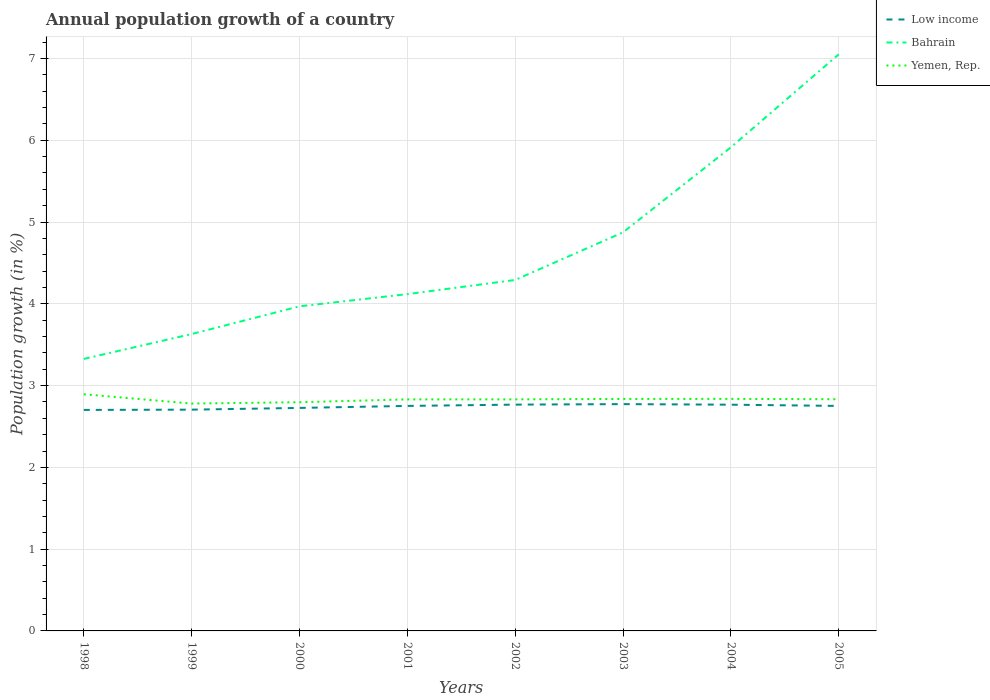How many different coloured lines are there?
Offer a very short reply. 3. Across all years, what is the maximum annual population growth in Yemen, Rep.?
Offer a very short reply. 2.78. In which year was the annual population growth in Yemen, Rep. maximum?
Offer a very short reply. 1999. What is the total annual population growth in Low income in the graph?
Provide a short and direct response. -0.06. What is the difference between the highest and the second highest annual population growth in Bahrain?
Your answer should be compact. 3.72. Is the annual population growth in Bahrain strictly greater than the annual population growth in Low income over the years?
Your answer should be compact. No. How many years are there in the graph?
Offer a very short reply. 8. What is the difference between two consecutive major ticks on the Y-axis?
Your response must be concise. 1. Where does the legend appear in the graph?
Your response must be concise. Top right. How many legend labels are there?
Offer a very short reply. 3. How are the legend labels stacked?
Give a very brief answer. Vertical. What is the title of the graph?
Ensure brevity in your answer.  Annual population growth of a country. What is the label or title of the Y-axis?
Ensure brevity in your answer.  Population growth (in %). What is the Population growth (in %) in Low income in 1998?
Keep it short and to the point. 2.7. What is the Population growth (in %) of Bahrain in 1998?
Provide a short and direct response. 3.33. What is the Population growth (in %) of Yemen, Rep. in 1998?
Your response must be concise. 2.89. What is the Population growth (in %) in Low income in 1999?
Provide a succinct answer. 2.71. What is the Population growth (in %) in Bahrain in 1999?
Your response must be concise. 3.63. What is the Population growth (in %) in Yemen, Rep. in 1999?
Make the answer very short. 2.78. What is the Population growth (in %) of Low income in 2000?
Keep it short and to the point. 2.73. What is the Population growth (in %) in Bahrain in 2000?
Offer a very short reply. 3.97. What is the Population growth (in %) in Yemen, Rep. in 2000?
Give a very brief answer. 2.8. What is the Population growth (in %) of Low income in 2001?
Provide a succinct answer. 2.75. What is the Population growth (in %) in Bahrain in 2001?
Provide a succinct answer. 4.12. What is the Population growth (in %) of Yemen, Rep. in 2001?
Your answer should be very brief. 2.83. What is the Population growth (in %) in Low income in 2002?
Provide a succinct answer. 2.77. What is the Population growth (in %) of Bahrain in 2002?
Ensure brevity in your answer.  4.29. What is the Population growth (in %) in Yemen, Rep. in 2002?
Provide a short and direct response. 2.83. What is the Population growth (in %) of Low income in 2003?
Provide a short and direct response. 2.77. What is the Population growth (in %) of Bahrain in 2003?
Provide a short and direct response. 4.87. What is the Population growth (in %) in Yemen, Rep. in 2003?
Give a very brief answer. 2.84. What is the Population growth (in %) of Low income in 2004?
Provide a short and direct response. 2.77. What is the Population growth (in %) in Bahrain in 2004?
Your response must be concise. 5.91. What is the Population growth (in %) of Yemen, Rep. in 2004?
Your response must be concise. 2.84. What is the Population growth (in %) in Low income in 2005?
Your answer should be very brief. 2.75. What is the Population growth (in %) in Bahrain in 2005?
Ensure brevity in your answer.  7.05. What is the Population growth (in %) of Yemen, Rep. in 2005?
Provide a short and direct response. 2.83. Across all years, what is the maximum Population growth (in %) in Low income?
Keep it short and to the point. 2.77. Across all years, what is the maximum Population growth (in %) of Bahrain?
Ensure brevity in your answer.  7.05. Across all years, what is the maximum Population growth (in %) of Yemen, Rep.?
Make the answer very short. 2.89. Across all years, what is the minimum Population growth (in %) in Low income?
Offer a terse response. 2.7. Across all years, what is the minimum Population growth (in %) in Bahrain?
Your response must be concise. 3.33. Across all years, what is the minimum Population growth (in %) of Yemen, Rep.?
Give a very brief answer. 2.78. What is the total Population growth (in %) in Low income in the graph?
Your answer should be compact. 21.95. What is the total Population growth (in %) of Bahrain in the graph?
Your answer should be very brief. 37.17. What is the total Population growth (in %) of Yemen, Rep. in the graph?
Provide a succinct answer. 22.64. What is the difference between the Population growth (in %) in Low income in 1998 and that in 1999?
Your response must be concise. -0. What is the difference between the Population growth (in %) in Bahrain in 1998 and that in 1999?
Keep it short and to the point. -0.3. What is the difference between the Population growth (in %) of Yemen, Rep. in 1998 and that in 1999?
Provide a succinct answer. 0.11. What is the difference between the Population growth (in %) of Low income in 1998 and that in 2000?
Offer a very short reply. -0.02. What is the difference between the Population growth (in %) in Bahrain in 1998 and that in 2000?
Your response must be concise. -0.64. What is the difference between the Population growth (in %) of Yemen, Rep. in 1998 and that in 2000?
Provide a short and direct response. 0.1. What is the difference between the Population growth (in %) in Low income in 1998 and that in 2001?
Your response must be concise. -0.05. What is the difference between the Population growth (in %) in Bahrain in 1998 and that in 2001?
Provide a short and direct response. -0.79. What is the difference between the Population growth (in %) in Yemen, Rep. in 1998 and that in 2001?
Your response must be concise. 0.06. What is the difference between the Population growth (in %) of Low income in 1998 and that in 2002?
Offer a terse response. -0.06. What is the difference between the Population growth (in %) of Bahrain in 1998 and that in 2002?
Provide a succinct answer. -0.97. What is the difference between the Population growth (in %) of Yemen, Rep. in 1998 and that in 2002?
Give a very brief answer. 0.06. What is the difference between the Population growth (in %) of Low income in 1998 and that in 2003?
Your answer should be compact. -0.07. What is the difference between the Population growth (in %) in Bahrain in 1998 and that in 2003?
Your answer should be very brief. -1.55. What is the difference between the Population growth (in %) in Yemen, Rep. in 1998 and that in 2003?
Offer a terse response. 0.06. What is the difference between the Population growth (in %) of Low income in 1998 and that in 2004?
Make the answer very short. -0.06. What is the difference between the Population growth (in %) of Bahrain in 1998 and that in 2004?
Offer a very short reply. -2.59. What is the difference between the Population growth (in %) in Yemen, Rep. in 1998 and that in 2004?
Offer a terse response. 0.06. What is the difference between the Population growth (in %) in Low income in 1998 and that in 2005?
Give a very brief answer. -0.05. What is the difference between the Population growth (in %) of Bahrain in 1998 and that in 2005?
Make the answer very short. -3.72. What is the difference between the Population growth (in %) in Yemen, Rep. in 1998 and that in 2005?
Provide a short and direct response. 0.06. What is the difference between the Population growth (in %) of Low income in 1999 and that in 2000?
Give a very brief answer. -0.02. What is the difference between the Population growth (in %) of Bahrain in 1999 and that in 2000?
Provide a short and direct response. -0.34. What is the difference between the Population growth (in %) of Yemen, Rep. in 1999 and that in 2000?
Offer a very short reply. -0.02. What is the difference between the Population growth (in %) in Low income in 1999 and that in 2001?
Make the answer very short. -0.05. What is the difference between the Population growth (in %) in Bahrain in 1999 and that in 2001?
Provide a short and direct response. -0.49. What is the difference between the Population growth (in %) of Yemen, Rep. in 1999 and that in 2001?
Make the answer very short. -0.05. What is the difference between the Population growth (in %) in Low income in 1999 and that in 2002?
Your response must be concise. -0.06. What is the difference between the Population growth (in %) in Bahrain in 1999 and that in 2002?
Your response must be concise. -0.66. What is the difference between the Population growth (in %) in Yemen, Rep. in 1999 and that in 2002?
Make the answer very short. -0.05. What is the difference between the Population growth (in %) in Low income in 1999 and that in 2003?
Give a very brief answer. -0.07. What is the difference between the Population growth (in %) in Bahrain in 1999 and that in 2003?
Make the answer very short. -1.24. What is the difference between the Population growth (in %) of Yemen, Rep. in 1999 and that in 2003?
Provide a short and direct response. -0.06. What is the difference between the Population growth (in %) of Low income in 1999 and that in 2004?
Keep it short and to the point. -0.06. What is the difference between the Population growth (in %) of Bahrain in 1999 and that in 2004?
Your answer should be compact. -2.28. What is the difference between the Population growth (in %) in Yemen, Rep. in 1999 and that in 2004?
Ensure brevity in your answer.  -0.06. What is the difference between the Population growth (in %) of Low income in 1999 and that in 2005?
Your response must be concise. -0.05. What is the difference between the Population growth (in %) of Bahrain in 1999 and that in 2005?
Your response must be concise. -3.42. What is the difference between the Population growth (in %) in Yemen, Rep. in 1999 and that in 2005?
Make the answer very short. -0.05. What is the difference between the Population growth (in %) of Low income in 2000 and that in 2001?
Your response must be concise. -0.02. What is the difference between the Population growth (in %) of Bahrain in 2000 and that in 2001?
Ensure brevity in your answer.  -0.15. What is the difference between the Population growth (in %) of Yemen, Rep. in 2000 and that in 2001?
Keep it short and to the point. -0.03. What is the difference between the Population growth (in %) of Low income in 2000 and that in 2002?
Offer a very short reply. -0.04. What is the difference between the Population growth (in %) of Bahrain in 2000 and that in 2002?
Offer a very short reply. -0.32. What is the difference between the Population growth (in %) of Yemen, Rep. in 2000 and that in 2002?
Provide a succinct answer. -0.04. What is the difference between the Population growth (in %) of Low income in 2000 and that in 2003?
Provide a short and direct response. -0.05. What is the difference between the Population growth (in %) in Bahrain in 2000 and that in 2003?
Your answer should be compact. -0.9. What is the difference between the Population growth (in %) of Yemen, Rep. in 2000 and that in 2003?
Offer a terse response. -0.04. What is the difference between the Population growth (in %) of Low income in 2000 and that in 2004?
Ensure brevity in your answer.  -0.04. What is the difference between the Population growth (in %) of Bahrain in 2000 and that in 2004?
Offer a terse response. -1.94. What is the difference between the Population growth (in %) of Yemen, Rep. in 2000 and that in 2004?
Your answer should be very brief. -0.04. What is the difference between the Population growth (in %) in Low income in 2000 and that in 2005?
Your answer should be very brief. -0.02. What is the difference between the Population growth (in %) of Bahrain in 2000 and that in 2005?
Offer a terse response. -3.08. What is the difference between the Population growth (in %) of Yemen, Rep. in 2000 and that in 2005?
Your answer should be very brief. -0.04. What is the difference between the Population growth (in %) in Low income in 2001 and that in 2002?
Your answer should be very brief. -0.02. What is the difference between the Population growth (in %) of Bahrain in 2001 and that in 2002?
Offer a very short reply. -0.17. What is the difference between the Population growth (in %) in Yemen, Rep. in 2001 and that in 2002?
Your answer should be very brief. -0. What is the difference between the Population growth (in %) of Low income in 2001 and that in 2003?
Your response must be concise. -0.02. What is the difference between the Population growth (in %) in Bahrain in 2001 and that in 2003?
Make the answer very short. -0.76. What is the difference between the Population growth (in %) of Yemen, Rep. in 2001 and that in 2003?
Your answer should be compact. -0.01. What is the difference between the Population growth (in %) in Low income in 2001 and that in 2004?
Your answer should be compact. -0.01. What is the difference between the Population growth (in %) in Bahrain in 2001 and that in 2004?
Provide a succinct answer. -1.79. What is the difference between the Population growth (in %) of Yemen, Rep. in 2001 and that in 2004?
Offer a terse response. -0.01. What is the difference between the Population growth (in %) of Low income in 2001 and that in 2005?
Ensure brevity in your answer.  0. What is the difference between the Population growth (in %) of Bahrain in 2001 and that in 2005?
Make the answer very short. -2.93. What is the difference between the Population growth (in %) of Yemen, Rep. in 2001 and that in 2005?
Give a very brief answer. -0. What is the difference between the Population growth (in %) of Low income in 2002 and that in 2003?
Ensure brevity in your answer.  -0.01. What is the difference between the Population growth (in %) of Bahrain in 2002 and that in 2003?
Provide a succinct answer. -0.58. What is the difference between the Population growth (in %) of Yemen, Rep. in 2002 and that in 2003?
Your response must be concise. -0.01. What is the difference between the Population growth (in %) of Low income in 2002 and that in 2004?
Provide a succinct answer. 0. What is the difference between the Population growth (in %) in Bahrain in 2002 and that in 2004?
Your response must be concise. -1.62. What is the difference between the Population growth (in %) in Yemen, Rep. in 2002 and that in 2004?
Your response must be concise. -0.01. What is the difference between the Population growth (in %) of Low income in 2002 and that in 2005?
Offer a very short reply. 0.02. What is the difference between the Population growth (in %) of Bahrain in 2002 and that in 2005?
Keep it short and to the point. -2.76. What is the difference between the Population growth (in %) of Yemen, Rep. in 2002 and that in 2005?
Give a very brief answer. -0. What is the difference between the Population growth (in %) in Low income in 2003 and that in 2004?
Your response must be concise. 0.01. What is the difference between the Population growth (in %) of Bahrain in 2003 and that in 2004?
Offer a very short reply. -1.04. What is the difference between the Population growth (in %) of Yemen, Rep. in 2003 and that in 2004?
Ensure brevity in your answer.  -0. What is the difference between the Population growth (in %) in Low income in 2003 and that in 2005?
Ensure brevity in your answer.  0.02. What is the difference between the Population growth (in %) in Bahrain in 2003 and that in 2005?
Give a very brief answer. -2.18. What is the difference between the Population growth (in %) in Yemen, Rep. in 2003 and that in 2005?
Make the answer very short. 0. What is the difference between the Population growth (in %) in Low income in 2004 and that in 2005?
Offer a very short reply. 0.02. What is the difference between the Population growth (in %) of Bahrain in 2004 and that in 2005?
Offer a terse response. -1.14. What is the difference between the Population growth (in %) of Yemen, Rep. in 2004 and that in 2005?
Provide a succinct answer. 0. What is the difference between the Population growth (in %) of Low income in 1998 and the Population growth (in %) of Bahrain in 1999?
Keep it short and to the point. -0.93. What is the difference between the Population growth (in %) of Low income in 1998 and the Population growth (in %) of Yemen, Rep. in 1999?
Your response must be concise. -0.08. What is the difference between the Population growth (in %) of Bahrain in 1998 and the Population growth (in %) of Yemen, Rep. in 1999?
Provide a short and direct response. 0.55. What is the difference between the Population growth (in %) of Low income in 1998 and the Population growth (in %) of Bahrain in 2000?
Provide a short and direct response. -1.27. What is the difference between the Population growth (in %) of Low income in 1998 and the Population growth (in %) of Yemen, Rep. in 2000?
Give a very brief answer. -0.09. What is the difference between the Population growth (in %) of Bahrain in 1998 and the Population growth (in %) of Yemen, Rep. in 2000?
Make the answer very short. 0.53. What is the difference between the Population growth (in %) of Low income in 1998 and the Population growth (in %) of Bahrain in 2001?
Ensure brevity in your answer.  -1.42. What is the difference between the Population growth (in %) in Low income in 1998 and the Population growth (in %) in Yemen, Rep. in 2001?
Your answer should be compact. -0.13. What is the difference between the Population growth (in %) of Bahrain in 1998 and the Population growth (in %) of Yemen, Rep. in 2001?
Offer a terse response. 0.49. What is the difference between the Population growth (in %) in Low income in 1998 and the Population growth (in %) in Bahrain in 2002?
Your response must be concise. -1.59. What is the difference between the Population growth (in %) in Low income in 1998 and the Population growth (in %) in Yemen, Rep. in 2002?
Your answer should be compact. -0.13. What is the difference between the Population growth (in %) in Bahrain in 1998 and the Population growth (in %) in Yemen, Rep. in 2002?
Ensure brevity in your answer.  0.49. What is the difference between the Population growth (in %) in Low income in 1998 and the Population growth (in %) in Bahrain in 2003?
Give a very brief answer. -2.17. What is the difference between the Population growth (in %) in Low income in 1998 and the Population growth (in %) in Yemen, Rep. in 2003?
Give a very brief answer. -0.13. What is the difference between the Population growth (in %) of Bahrain in 1998 and the Population growth (in %) of Yemen, Rep. in 2003?
Give a very brief answer. 0.49. What is the difference between the Population growth (in %) of Low income in 1998 and the Population growth (in %) of Bahrain in 2004?
Your answer should be very brief. -3.21. What is the difference between the Population growth (in %) in Low income in 1998 and the Population growth (in %) in Yemen, Rep. in 2004?
Ensure brevity in your answer.  -0.13. What is the difference between the Population growth (in %) in Bahrain in 1998 and the Population growth (in %) in Yemen, Rep. in 2004?
Your answer should be compact. 0.49. What is the difference between the Population growth (in %) in Low income in 1998 and the Population growth (in %) in Bahrain in 2005?
Your answer should be compact. -4.35. What is the difference between the Population growth (in %) in Low income in 1998 and the Population growth (in %) in Yemen, Rep. in 2005?
Ensure brevity in your answer.  -0.13. What is the difference between the Population growth (in %) in Bahrain in 1998 and the Population growth (in %) in Yemen, Rep. in 2005?
Offer a very short reply. 0.49. What is the difference between the Population growth (in %) in Low income in 1999 and the Population growth (in %) in Bahrain in 2000?
Your answer should be compact. -1.26. What is the difference between the Population growth (in %) in Low income in 1999 and the Population growth (in %) in Yemen, Rep. in 2000?
Keep it short and to the point. -0.09. What is the difference between the Population growth (in %) of Bahrain in 1999 and the Population growth (in %) of Yemen, Rep. in 2000?
Keep it short and to the point. 0.83. What is the difference between the Population growth (in %) in Low income in 1999 and the Population growth (in %) in Bahrain in 2001?
Provide a succinct answer. -1.41. What is the difference between the Population growth (in %) of Low income in 1999 and the Population growth (in %) of Yemen, Rep. in 2001?
Make the answer very short. -0.13. What is the difference between the Population growth (in %) in Bahrain in 1999 and the Population growth (in %) in Yemen, Rep. in 2001?
Give a very brief answer. 0.8. What is the difference between the Population growth (in %) in Low income in 1999 and the Population growth (in %) in Bahrain in 2002?
Keep it short and to the point. -1.59. What is the difference between the Population growth (in %) in Low income in 1999 and the Population growth (in %) in Yemen, Rep. in 2002?
Offer a terse response. -0.13. What is the difference between the Population growth (in %) of Bahrain in 1999 and the Population growth (in %) of Yemen, Rep. in 2002?
Make the answer very short. 0.8. What is the difference between the Population growth (in %) in Low income in 1999 and the Population growth (in %) in Bahrain in 2003?
Ensure brevity in your answer.  -2.17. What is the difference between the Population growth (in %) in Low income in 1999 and the Population growth (in %) in Yemen, Rep. in 2003?
Ensure brevity in your answer.  -0.13. What is the difference between the Population growth (in %) of Bahrain in 1999 and the Population growth (in %) of Yemen, Rep. in 2003?
Provide a short and direct response. 0.79. What is the difference between the Population growth (in %) of Low income in 1999 and the Population growth (in %) of Bahrain in 2004?
Your answer should be very brief. -3.21. What is the difference between the Population growth (in %) of Low income in 1999 and the Population growth (in %) of Yemen, Rep. in 2004?
Your answer should be very brief. -0.13. What is the difference between the Population growth (in %) in Bahrain in 1999 and the Population growth (in %) in Yemen, Rep. in 2004?
Make the answer very short. 0.79. What is the difference between the Population growth (in %) in Low income in 1999 and the Population growth (in %) in Bahrain in 2005?
Provide a short and direct response. -4.34. What is the difference between the Population growth (in %) in Low income in 1999 and the Population growth (in %) in Yemen, Rep. in 2005?
Your answer should be compact. -0.13. What is the difference between the Population growth (in %) of Bahrain in 1999 and the Population growth (in %) of Yemen, Rep. in 2005?
Your answer should be compact. 0.8. What is the difference between the Population growth (in %) in Low income in 2000 and the Population growth (in %) in Bahrain in 2001?
Your answer should be compact. -1.39. What is the difference between the Population growth (in %) in Low income in 2000 and the Population growth (in %) in Yemen, Rep. in 2001?
Provide a short and direct response. -0.1. What is the difference between the Population growth (in %) of Bahrain in 2000 and the Population growth (in %) of Yemen, Rep. in 2001?
Your answer should be compact. 1.14. What is the difference between the Population growth (in %) in Low income in 2000 and the Population growth (in %) in Bahrain in 2002?
Your answer should be compact. -1.56. What is the difference between the Population growth (in %) of Low income in 2000 and the Population growth (in %) of Yemen, Rep. in 2002?
Your response must be concise. -0.1. What is the difference between the Population growth (in %) in Bahrain in 2000 and the Population growth (in %) in Yemen, Rep. in 2002?
Keep it short and to the point. 1.14. What is the difference between the Population growth (in %) of Low income in 2000 and the Population growth (in %) of Bahrain in 2003?
Your answer should be compact. -2.15. What is the difference between the Population growth (in %) of Low income in 2000 and the Population growth (in %) of Yemen, Rep. in 2003?
Keep it short and to the point. -0.11. What is the difference between the Population growth (in %) of Bahrain in 2000 and the Population growth (in %) of Yemen, Rep. in 2003?
Provide a short and direct response. 1.13. What is the difference between the Population growth (in %) of Low income in 2000 and the Population growth (in %) of Bahrain in 2004?
Give a very brief answer. -3.19. What is the difference between the Population growth (in %) of Low income in 2000 and the Population growth (in %) of Yemen, Rep. in 2004?
Offer a terse response. -0.11. What is the difference between the Population growth (in %) of Bahrain in 2000 and the Population growth (in %) of Yemen, Rep. in 2004?
Give a very brief answer. 1.13. What is the difference between the Population growth (in %) of Low income in 2000 and the Population growth (in %) of Bahrain in 2005?
Offer a very short reply. -4.32. What is the difference between the Population growth (in %) in Low income in 2000 and the Population growth (in %) in Yemen, Rep. in 2005?
Make the answer very short. -0.11. What is the difference between the Population growth (in %) in Bahrain in 2000 and the Population growth (in %) in Yemen, Rep. in 2005?
Give a very brief answer. 1.14. What is the difference between the Population growth (in %) of Low income in 2001 and the Population growth (in %) of Bahrain in 2002?
Your answer should be very brief. -1.54. What is the difference between the Population growth (in %) of Low income in 2001 and the Population growth (in %) of Yemen, Rep. in 2002?
Give a very brief answer. -0.08. What is the difference between the Population growth (in %) in Bahrain in 2001 and the Population growth (in %) in Yemen, Rep. in 2002?
Keep it short and to the point. 1.29. What is the difference between the Population growth (in %) of Low income in 2001 and the Population growth (in %) of Bahrain in 2003?
Provide a short and direct response. -2.12. What is the difference between the Population growth (in %) in Low income in 2001 and the Population growth (in %) in Yemen, Rep. in 2003?
Provide a short and direct response. -0.09. What is the difference between the Population growth (in %) in Bahrain in 2001 and the Population growth (in %) in Yemen, Rep. in 2003?
Offer a very short reply. 1.28. What is the difference between the Population growth (in %) of Low income in 2001 and the Population growth (in %) of Bahrain in 2004?
Your answer should be compact. -3.16. What is the difference between the Population growth (in %) of Low income in 2001 and the Population growth (in %) of Yemen, Rep. in 2004?
Ensure brevity in your answer.  -0.09. What is the difference between the Population growth (in %) of Bahrain in 2001 and the Population growth (in %) of Yemen, Rep. in 2004?
Your answer should be compact. 1.28. What is the difference between the Population growth (in %) of Low income in 2001 and the Population growth (in %) of Bahrain in 2005?
Offer a terse response. -4.3. What is the difference between the Population growth (in %) in Low income in 2001 and the Population growth (in %) in Yemen, Rep. in 2005?
Ensure brevity in your answer.  -0.08. What is the difference between the Population growth (in %) of Bahrain in 2001 and the Population growth (in %) of Yemen, Rep. in 2005?
Your answer should be compact. 1.29. What is the difference between the Population growth (in %) in Low income in 2002 and the Population growth (in %) in Bahrain in 2003?
Your response must be concise. -2.11. What is the difference between the Population growth (in %) of Low income in 2002 and the Population growth (in %) of Yemen, Rep. in 2003?
Provide a short and direct response. -0.07. What is the difference between the Population growth (in %) of Bahrain in 2002 and the Population growth (in %) of Yemen, Rep. in 2003?
Provide a succinct answer. 1.45. What is the difference between the Population growth (in %) of Low income in 2002 and the Population growth (in %) of Bahrain in 2004?
Your response must be concise. -3.15. What is the difference between the Population growth (in %) in Low income in 2002 and the Population growth (in %) in Yemen, Rep. in 2004?
Keep it short and to the point. -0.07. What is the difference between the Population growth (in %) of Bahrain in 2002 and the Population growth (in %) of Yemen, Rep. in 2004?
Make the answer very short. 1.45. What is the difference between the Population growth (in %) of Low income in 2002 and the Population growth (in %) of Bahrain in 2005?
Give a very brief answer. -4.28. What is the difference between the Population growth (in %) of Low income in 2002 and the Population growth (in %) of Yemen, Rep. in 2005?
Keep it short and to the point. -0.07. What is the difference between the Population growth (in %) of Bahrain in 2002 and the Population growth (in %) of Yemen, Rep. in 2005?
Your answer should be compact. 1.46. What is the difference between the Population growth (in %) in Low income in 2003 and the Population growth (in %) in Bahrain in 2004?
Your answer should be compact. -3.14. What is the difference between the Population growth (in %) of Low income in 2003 and the Population growth (in %) of Yemen, Rep. in 2004?
Give a very brief answer. -0.06. What is the difference between the Population growth (in %) in Bahrain in 2003 and the Population growth (in %) in Yemen, Rep. in 2004?
Ensure brevity in your answer.  2.04. What is the difference between the Population growth (in %) in Low income in 2003 and the Population growth (in %) in Bahrain in 2005?
Your answer should be very brief. -4.28. What is the difference between the Population growth (in %) in Low income in 2003 and the Population growth (in %) in Yemen, Rep. in 2005?
Make the answer very short. -0.06. What is the difference between the Population growth (in %) in Bahrain in 2003 and the Population growth (in %) in Yemen, Rep. in 2005?
Offer a very short reply. 2.04. What is the difference between the Population growth (in %) of Low income in 2004 and the Population growth (in %) of Bahrain in 2005?
Ensure brevity in your answer.  -4.28. What is the difference between the Population growth (in %) in Low income in 2004 and the Population growth (in %) in Yemen, Rep. in 2005?
Give a very brief answer. -0.07. What is the difference between the Population growth (in %) in Bahrain in 2004 and the Population growth (in %) in Yemen, Rep. in 2005?
Provide a short and direct response. 3.08. What is the average Population growth (in %) in Low income per year?
Offer a very short reply. 2.74. What is the average Population growth (in %) in Bahrain per year?
Make the answer very short. 4.65. What is the average Population growth (in %) of Yemen, Rep. per year?
Provide a succinct answer. 2.83. In the year 1998, what is the difference between the Population growth (in %) in Low income and Population growth (in %) in Bahrain?
Your answer should be very brief. -0.62. In the year 1998, what is the difference between the Population growth (in %) of Low income and Population growth (in %) of Yemen, Rep.?
Make the answer very short. -0.19. In the year 1998, what is the difference between the Population growth (in %) of Bahrain and Population growth (in %) of Yemen, Rep.?
Provide a short and direct response. 0.43. In the year 1999, what is the difference between the Population growth (in %) of Low income and Population growth (in %) of Bahrain?
Offer a terse response. -0.92. In the year 1999, what is the difference between the Population growth (in %) of Low income and Population growth (in %) of Yemen, Rep.?
Ensure brevity in your answer.  -0.07. In the year 1999, what is the difference between the Population growth (in %) in Bahrain and Population growth (in %) in Yemen, Rep.?
Offer a very short reply. 0.85. In the year 2000, what is the difference between the Population growth (in %) in Low income and Population growth (in %) in Bahrain?
Give a very brief answer. -1.24. In the year 2000, what is the difference between the Population growth (in %) of Low income and Population growth (in %) of Yemen, Rep.?
Keep it short and to the point. -0.07. In the year 2000, what is the difference between the Population growth (in %) in Bahrain and Population growth (in %) in Yemen, Rep.?
Make the answer very short. 1.17. In the year 2001, what is the difference between the Population growth (in %) in Low income and Population growth (in %) in Bahrain?
Give a very brief answer. -1.37. In the year 2001, what is the difference between the Population growth (in %) of Low income and Population growth (in %) of Yemen, Rep.?
Your answer should be very brief. -0.08. In the year 2001, what is the difference between the Population growth (in %) in Bahrain and Population growth (in %) in Yemen, Rep.?
Your response must be concise. 1.29. In the year 2002, what is the difference between the Population growth (in %) in Low income and Population growth (in %) in Bahrain?
Offer a terse response. -1.52. In the year 2002, what is the difference between the Population growth (in %) of Low income and Population growth (in %) of Yemen, Rep.?
Your answer should be compact. -0.06. In the year 2002, what is the difference between the Population growth (in %) in Bahrain and Population growth (in %) in Yemen, Rep.?
Offer a very short reply. 1.46. In the year 2003, what is the difference between the Population growth (in %) in Low income and Population growth (in %) in Bahrain?
Ensure brevity in your answer.  -2.1. In the year 2003, what is the difference between the Population growth (in %) of Low income and Population growth (in %) of Yemen, Rep.?
Offer a terse response. -0.06. In the year 2003, what is the difference between the Population growth (in %) in Bahrain and Population growth (in %) in Yemen, Rep.?
Keep it short and to the point. 2.04. In the year 2004, what is the difference between the Population growth (in %) in Low income and Population growth (in %) in Bahrain?
Your response must be concise. -3.15. In the year 2004, what is the difference between the Population growth (in %) in Low income and Population growth (in %) in Yemen, Rep.?
Offer a terse response. -0.07. In the year 2004, what is the difference between the Population growth (in %) in Bahrain and Population growth (in %) in Yemen, Rep.?
Keep it short and to the point. 3.08. In the year 2005, what is the difference between the Population growth (in %) in Low income and Population growth (in %) in Bahrain?
Your answer should be very brief. -4.3. In the year 2005, what is the difference between the Population growth (in %) of Low income and Population growth (in %) of Yemen, Rep.?
Offer a very short reply. -0.08. In the year 2005, what is the difference between the Population growth (in %) in Bahrain and Population growth (in %) in Yemen, Rep.?
Make the answer very short. 4.22. What is the ratio of the Population growth (in %) in Bahrain in 1998 to that in 1999?
Give a very brief answer. 0.92. What is the ratio of the Population growth (in %) in Yemen, Rep. in 1998 to that in 1999?
Provide a succinct answer. 1.04. What is the ratio of the Population growth (in %) in Bahrain in 1998 to that in 2000?
Offer a terse response. 0.84. What is the ratio of the Population growth (in %) in Yemen, Rep. in 1998 to that in 2000?
Offer a terse response. 1.03. What is the ratio of the Population growth (in %) in Low income in 1998 to that in 2001?
Offer a very short reply. 0.98. What is the ratio of the Population growth (in %) in Bahrain in 1998 to that in 2001?
Keep it short and to the point. 0.81. What is the ratio of the Population growth (in %) in Yemen, Rep. in 1998 to that in 2001?
Your response must be concise. 1.02. What is the ratio of the Population growth (in %) in Low income in 1998 to that in 2002?
Ensure brevity in your answer.  0.98. What is the ratio of the Population growth (in %) of Bahrain in 1998 to that in 2002?
Your answer should be very brief. 0.78. What is the ratio of the Population growth (in %) of Yemen, Rep. in 1998 to that in 2002?
Provide a short and direct response. 1.02. What is the ratio of the Population growth (in %) in Low income in 1998 to that in 2003?
Provide a succinct answer. 0.97. What is the ratio of the Population growth (in %) of Bahrain in 1998 to that in 2003?
Keep it short and to the point. 0.68. What is the ratio of the Population growth (in %) of Yemen, Rep. in 1998 to that in 2003?
Make the answer very short. 1.02. What is the ratio of the Population growth (in %) in Low income in 1998 to that in 2004?
Your response must be concise. 0.98. What is the ratio of the Population growth (in %) in Bahrain in 1998 to that in 2004?
Offer a very short reply. 0.56. What is the ratio of the Population growth (in %) of Low income in 1998 to that in 2005?
Provide a short and direct response. 0.98. What is the ratio of the Population growth (in %) of Bahrain in 1998 to that in 2005?
Make the answer very short. 0.47. What is the ratio of the Population growth (in %) in Yemen, Rep. in 1998 to that in 2005?
Your answer should be very brief. 1.02. What is the ratio of the Population growth (in %) of Low income in 1999 to that in 2000?
Offer a very short reply. 0.99. What is the ratio of the Population growth (in %) of Bahrain in 1999 to that in 2000?
Keep it short and to the point. 0.91. What is the ratio of the Population growth (in %) in Low income in 1999 to that in 2001?
Your answer should be very brief. 0.98. What is the ratio of the Population growth (in %) of Bahrain in 1999 to that in 2001?
Your answer should be very brief. 0.88. What is the ratio of the Population growth (in %) of Yemen, Rep. in 1999 to that in 2001?
Provide a succinct answer. 0.98. What is the ratio of the Population growth (in %) of Low income in 1999 to that in 2002?
Make the answer very short. 0.98. What is the ratio of the Population growth (in %) in Bahrain in 1999 to that in 2002?
Keep it short and to the point. 0.85. What is the ratio of the Population growth (in %) of Yemen, Rep. in 1999 to that in 2002?
Ensure brevity in your answer.  0.98. What is the ratio of the Population growth (in %) of Low income in 1999 to that in 2003?
Your answer should be very brief. 0.98. What is the ratio of the Population growth (in %) in Bahrain in 1999 to that in 2003?
Make the answer very short. 0.74. What is the ratio of the Population growth (in %) in Low income in 1999 to that in 2004?
Your response must be concise. 0.98. What is the ratio of the Population growth (in %) in Bahrain in 1999 to that in 2004?
Your response must be concise. 0.61. What is the ratio of the Population growth (in %) in Yemen, Rep. in 1999 to that in 2004?
Provide a succinct answer. 0.98. What is the ratio of the Population growth (in %) of Low income in 1999 to that in 2005?
Your response must be concise. 0.98. What is the ratio of the Population growth (in %) in Bahrain in 1999 to that in 2005?
Provide a succinct answer. 0.51. What is the ratio of the Population growth (in %) in Yemen, Rep. in 1999 to that in 2005?
Your response must be concise. 0.98. What is the ratio of the Population growth (in %) of Low income in 2000 to that in 2001?
Your response must be concise. 0.99. What is the ratio of the Population growth (in %) of Bahrain in 2000 to that in 2001?
Make the answer very short. 0.96. What is the ratio of the Population growth (in %) in Yemen, Rep. in 2000 to that in 2001?
Provide a short and direct response. 0.99. What is the ratio of the Population growth (in %) of Low income in 2000 to that in 2002?
Keep it short and to the point. 0.99. What is the ratio of the Population growth (in %) in Bahrain in 2000 to that in 2002?
Your response must be concise. 0.92. What is the ratio of the Population growth (in %) in Yemen, Rep. in 2000 to that in 2002?
Keep it short and to the point. 0.99. What is the ratio of the Population growth (in %) of Low income in 2000 to that in 2003?
Offer a terse response. 0.98. What is the ratio of the Population growth (in %) of Bahrain in 2000 to that in 2003?
Keep it short and to the point. 0.81. What is the ratio of the Population growth (in %) in Yemen, Rep. in 2000 to that in 2003?
Offer a terse response. 0.99. What is the ratio of the Population growth (in %) of Low income in 2000 to that in 2004?
Keep it short and to the point. 0.99. What is the ratio of the Population growth (in %) in Bahrain in 2000 to that in 2004?
Make the answer very short. 0.67. What is the ratio of the Population growth (in %) of Yemen, Rep. in 2000 to that in 2004?
Your response must be concise. 0.99. What is the ratio of the Population growth (in %) in Bahrain in 2000 to that in 2005?
Make the answer very short. 0.56. What is the ratio of the Population growth (in %) in Yemen, Rep. in 2000 to that in 2005?
Offer a terse response. 0.99. What is the ratio of the Population growth (in %) of Low income in 2001 to that in 2002?
Your response must be concise. 0.99. What is the ratio of the Population growth (in %) of Bahrain in 2001 to that in 2002?
Offer a terse response. 0.96. What is the ratio of the Population growth (in %) in Yemen, Rep. in 2001 to that in 2002?
Your response must be concise. 1. What is the ratio of the Population growth (in %) in Bahrain in 2001 to that in 2003?
Offer a very short reply. 0.84. What is the ratio of the Population growth (in %) of Yemen, Rep. in 2001 to that in 2003?
Provide a short and direct response. 1. What is the ratio of the Population growth (in %) in Bahrain in 2001 to that in 2004?
Provide a succinct answer. 0.7. What is the ratio of the Population growth (in %) in Bahrain in 2001 to that in 2005?
Provide a succinct answer. 0.58. What is the ratio of the Population growth (in %) of Yemen, Rep. in 2001 to that in 2005?
Give a very brief answer. 1. What is the ratio of the Population growth (in %) of Low income in 2002 to that in 2003?
Provide a short and direct response. 1. What is the ratio of the Population growth (in %) of Bahrain in 2002 to that in 2003?
Offer a terse response. 0.88. What is the ratio of the Population growth (in %) of Bahrain in 2002 to that in 2004?
Offer a terse response. 0.73. What is the ratio of the Population growth (in %) in Yemen, Rep. in 2002 to that in 2004?
Your answer should be compact. 1. What is the ratio of the Population growth (in %) of Low income in 2002 to that in 2005?
Keep it short and to the point. 1.01. What is the ratio of the Population growth (in %) of Bahrain in 2002 to that in 2005?
Offer a very short reply. 0.61. What is the ratio of the Population growth (in %) in Yemen, Rep. in 2002 to that in 2005?
Your answer should be very brief. 1. What is the ratio of the Population growth (in %) in Low income in 2003 to that in 2004?
Your answer should be very brief. 1. What is the ratio of the Population growth (in %) of Bahrain in 2003 to that in 2004?
Give a very brief answer. 0.82. What is the ratio of the Population growth (in %) of Bahrain in 2003 to that in 2005?
Make the answer very short. 0.69. What is the ratio of the Population growth (in %) in Yemen, Rep. in 2003 to that in 2005?
Provide a short and direct response. 1. What is the ratio of the Population growth (in %) in Low income in 2004 to that in 2005?
Provide a succinct answer. 1.01. What is the ratio of the Population growth (in %) of Bahrain in 2004 to that in 2005?
Your answer should be very brief. 0.84. What is the difference between the highest and the second highest Population growth (in %) in Low income?
Keep it short and to the point. 0.01. What is the difference between the highest and the second highest Population growth (in %) in Bahrain?
Give a very brief answer. 1.14. What is the difference between the highest and the second highest Population growth (in %) in Yemen, Rep.?
Make the answer very short. 0.06. What is the difference between the highest and the lowest Population growth (in %) in Low income?
Offer a terse response. 0.07. What is the difference between the highest and the lowest Population growth (in %) in Bahrain?
Offer a terse response. 3.72. What is the difference between the highest and the lowest Population growth (in %) of Yemen, Rep.?
Offer a very short reply. 0.11. 